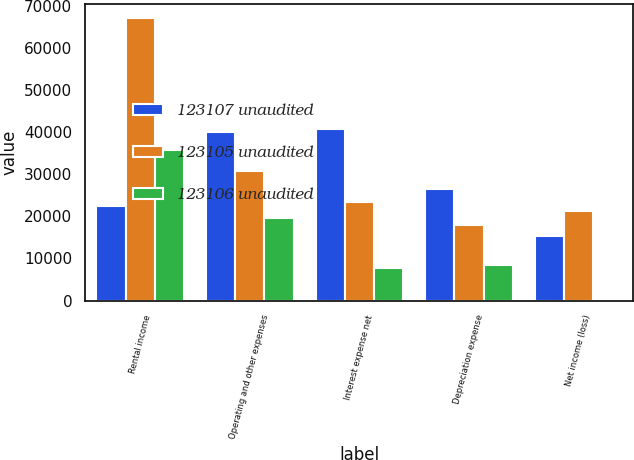Convert chart to OTSL. <chart><loc_0><loc_0><loc_500><loc_500><stacked_bar_chart><ecel><fcel>Rental income<fcel>Operating and other expenses<fcel>Interest expense net<fcel>Depreciation expense<fcel>Net income (loss)<nl><fcel>123107 unaudited<fcel>22450.5<fcel>40090<fcel>40791<fcel>26622<fcel>15428<nl><fcel>123105 unaudited<fcel>67207<fcel>30913<fcel>23545<fcel>18054<fcel>21356<nl><fcel>123106 unaudited<fcel>35826<fcel>19582<fcel>7648<fcel>8482<fcel>114<nl></chart> 